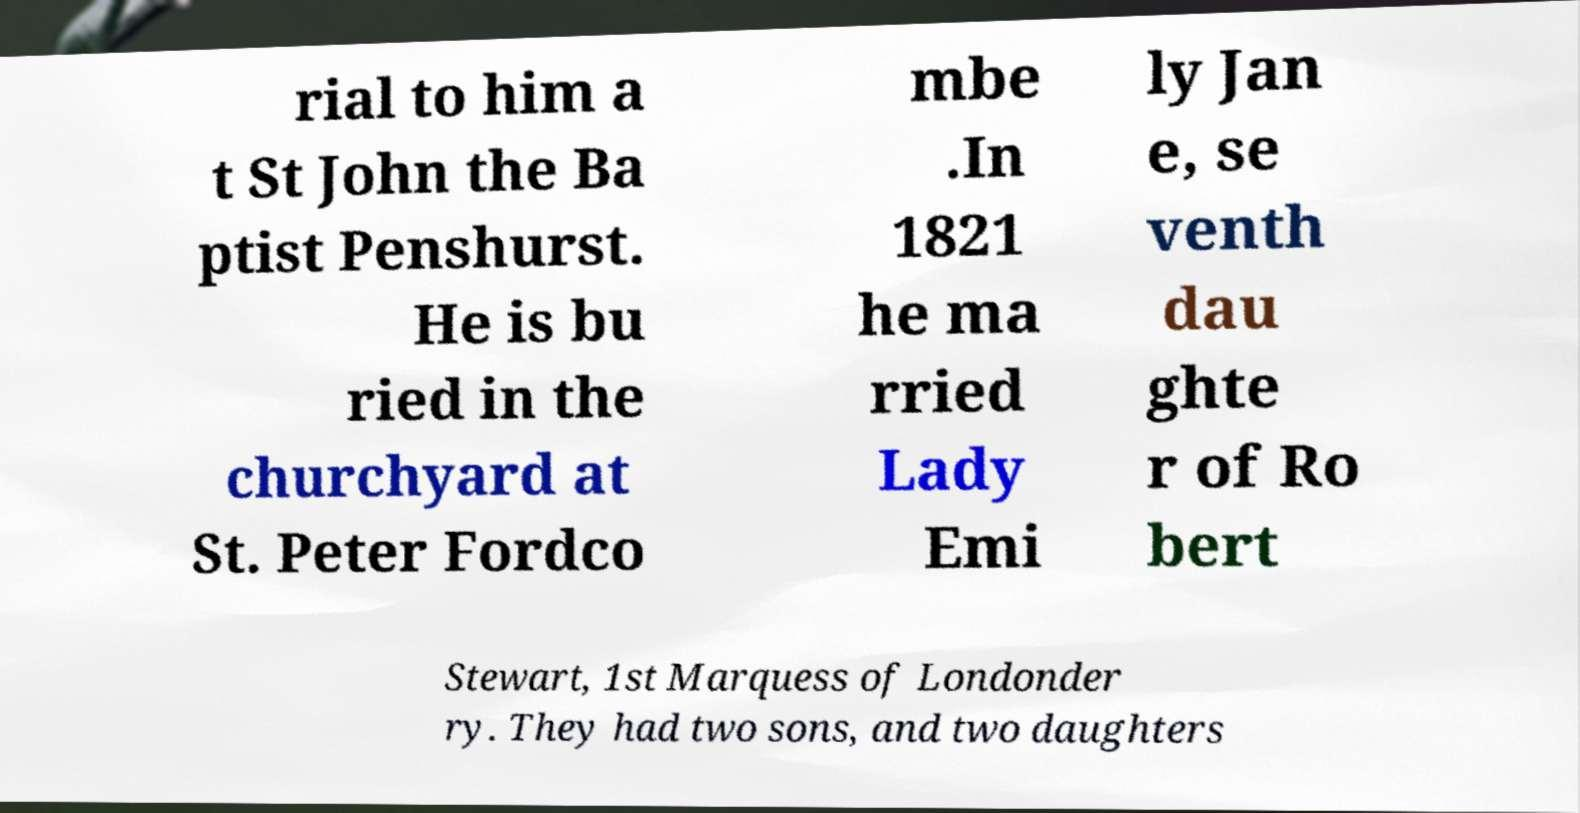Can you accurately transcribe the text from the provided image for me? rial to him a t St John the Ba ptist Penshurst. He is bu ried in the churchyard at St. Peter Fordco mbe .In 1821 he ma rried Lady Emi ly Jan e, se venth dau ghte r of Ro bert Stewart, 1st Marquess of Londonder ry. They had two sons, and two daughters 